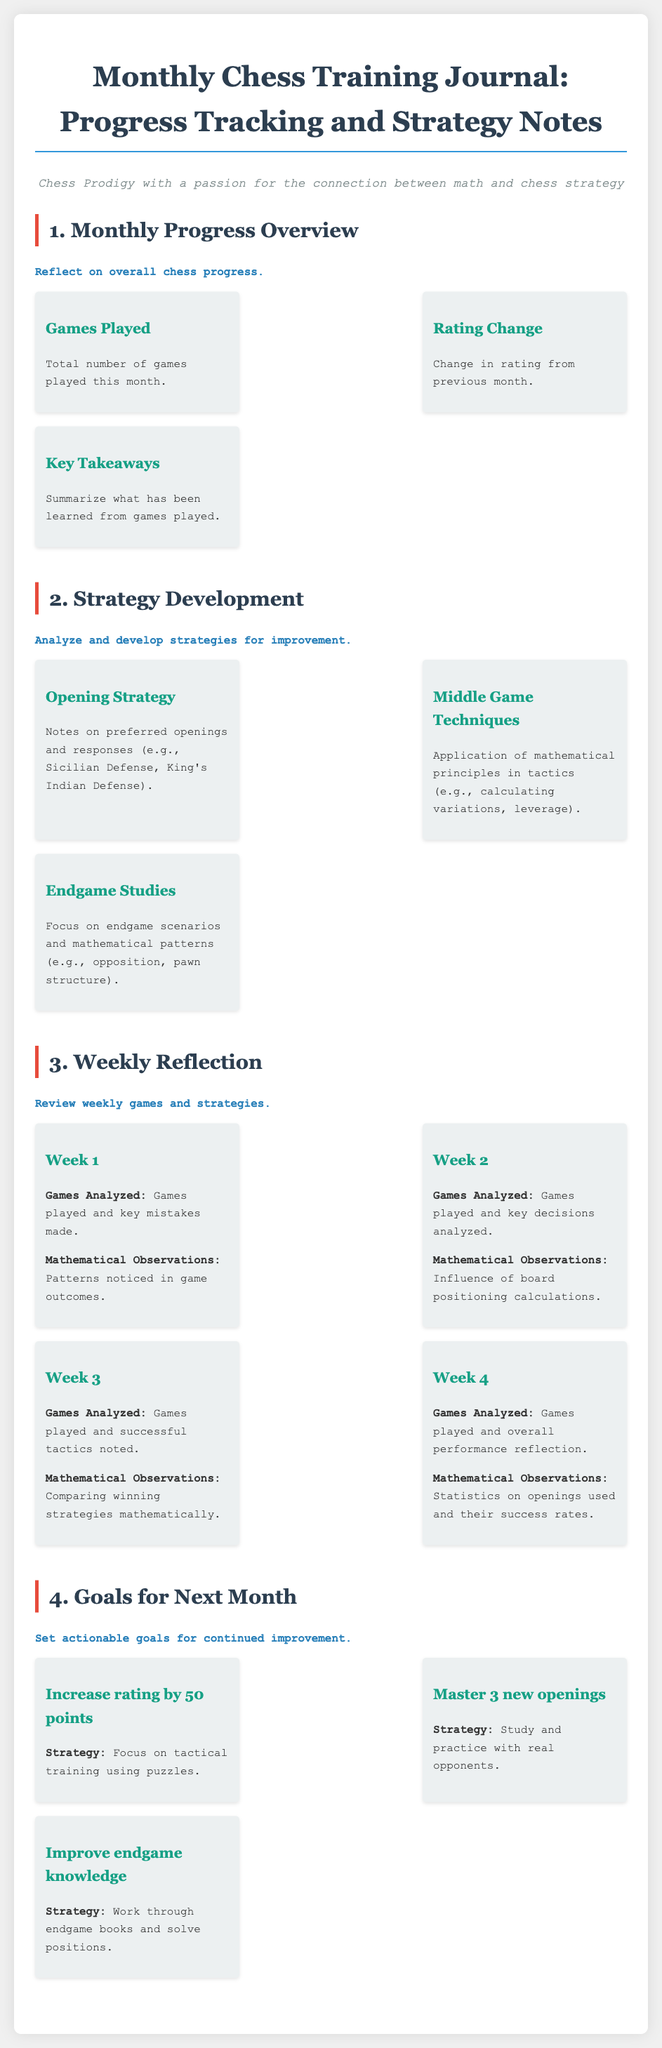What is the title of the document? The title of the document is prominently displayed as the heading at the top of the rendered document.
Answer: Monthly Chess Training Journal: Progress Tracking and Strategy Notes What is the total number of sections in the document? The number of sections is determined by counting the main headings in the document.
Answer: 4 What is one of the key takeaways from the Monthly Progress Overview section? A key takeaway refers to the summarized learnings from the Monthly Progress Overview section.
Answer: Summarize what has been learned from games played What are the goals set for the next month? The goals highlighted can be identified in the Goals for Next Month section.
Answer: Increase rating by 50 points, Master 3 new openings, Improve endgame knowledge What strategy is mentioned for mastering new openings? The strategy for mastering new openings is provided in the Goals for Next Month section under the relevant goal.
Answer: Study and practice with real opponents What week focuses on comparing winning strategies mathematically? The week focusing on this aspect can be found in the Weekly Reflection section.
Answer: Week 3 What mathematical principle is applied in Middle Game Techniques? The principle mentioned can be found in the Strategy Development section under Middle Game Techniques.
Answer: Calculating variations What are the two specific components listed under Endgame Studies? The components related to endgames can be identified in the Strategy Development section.
Answer: Focus on endgame scenarios and mathematical patterns How many games were analyzed in Week 2? The amount of games specifically analyzed is not quantitative but mentioned in the Weekly Reflection section for that week.
Answer: Games played and key decisions analyzed 